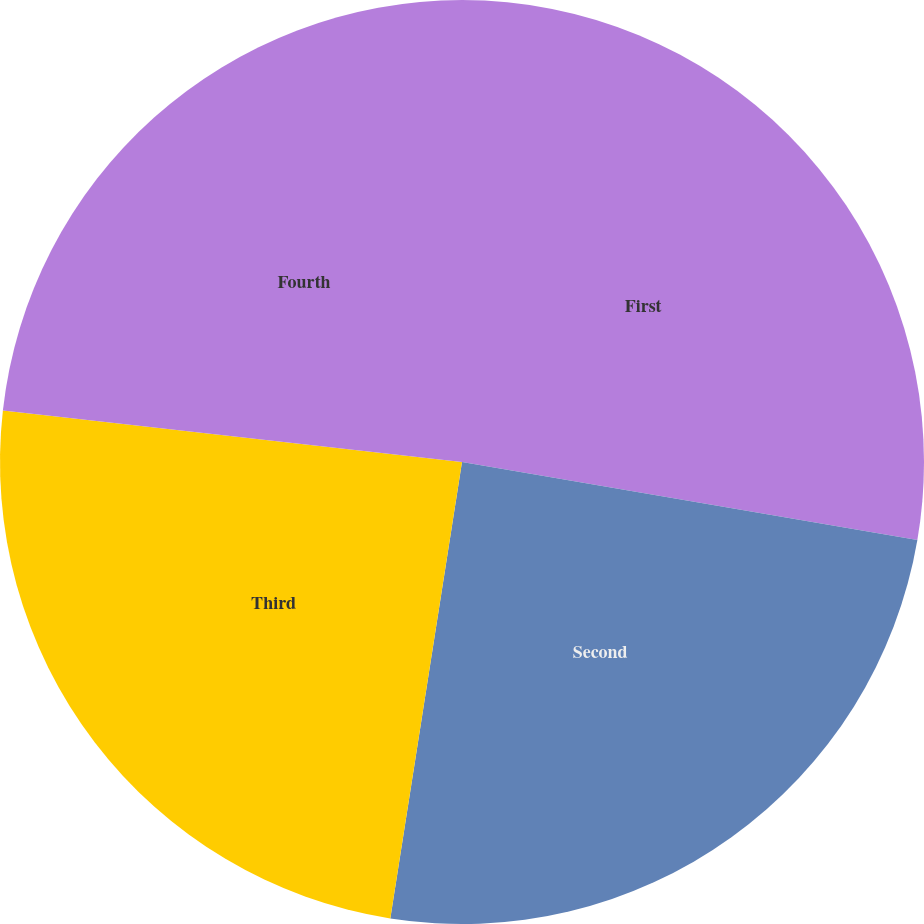<chart> <loc_0><loc_0><loc_500><loc_500><pie_chart><fcel>First<fcel>Second<fcel>Third<fcel>Fourth<nl><fcel>27.7%<fcel>24.78%<fcel>24.3%<fcel>23.22%<nl></chart> 